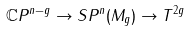<formula> <loc_0><loc_0><loc_500><loc_500>\mathbb { C } P ^ { n - g } \rightarrow S P ^ { n } ( M _ { g } ) \rightarrow T ^ { 2 g }</formula> 